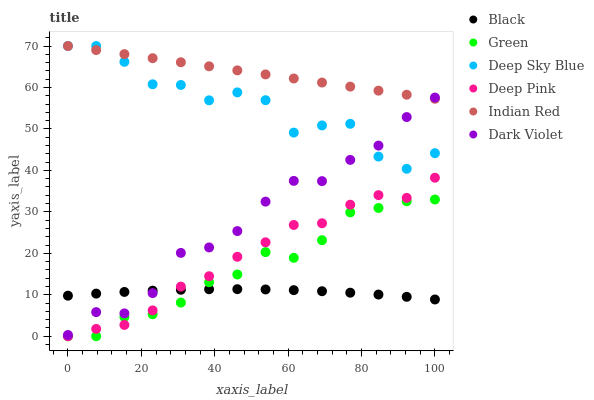Does Black have the minimum area under the curve?
Answer yes or no. Yes. Does Indian Red have the maximum area under the curve?
Answer yes or no. Yes. Does Deep Sky Blue have the minimum area under the curve?
Answer yes or no. No. Does Deep Sky Blue have the maximum area under the curve?
Answer yes or no. No. Is Indian Red the smoothest?
Answer yes or no. Yes. Is Deep Sky Blue the roughest?
Answer yes or no. Yes. Is Dark Violet the smoothest?
Answer yes or no. No. Is Dark Violet the roughest?
Answer yes or no. No. Does Deep Pink have the lowest value?
Answer yes or no. Yes. Does Deep Sky Blue have the lowest value?
Answer yes or no. No. Does Indian Red have the highest value?
Answer yes or no. Yes. Does Dark Violet have the highest value?
Answer yes or no. No. Is Green less than Indian Red?
Answer yes or no. Yes. Is Deep Sky Blue greater than Green?
Answer yes or no. Yes. Does Dark Violet intersect Black?
Answer yes or no. Yes. Is Dark Violet less than Black?
Answer yes or no. No. Is Dark Violet greater than Black?
Answer yes or no. No. Does Green intersect Indian Red?
Answer yes or no. No. 